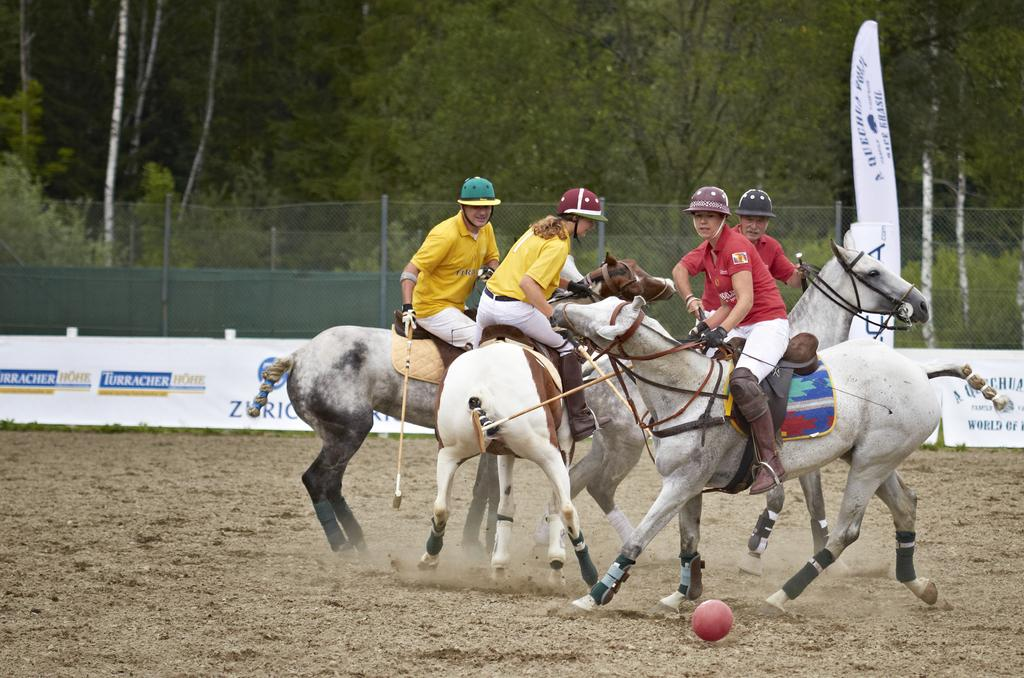How many people are playing polo in the image? There are four players in the image. What sport are the players engaged in? The players are playing polo. What can be seen in the background of the image? There is a banner and a fence in the image, and trees are on the other side of the fence. What type of rod is being used by the players in the image? There are no rods present in the image; the players are using polo mallets to play the sport. How many stitches are visible on the banner in the image? The number of stitches on the banner cannot be determined from the image. 